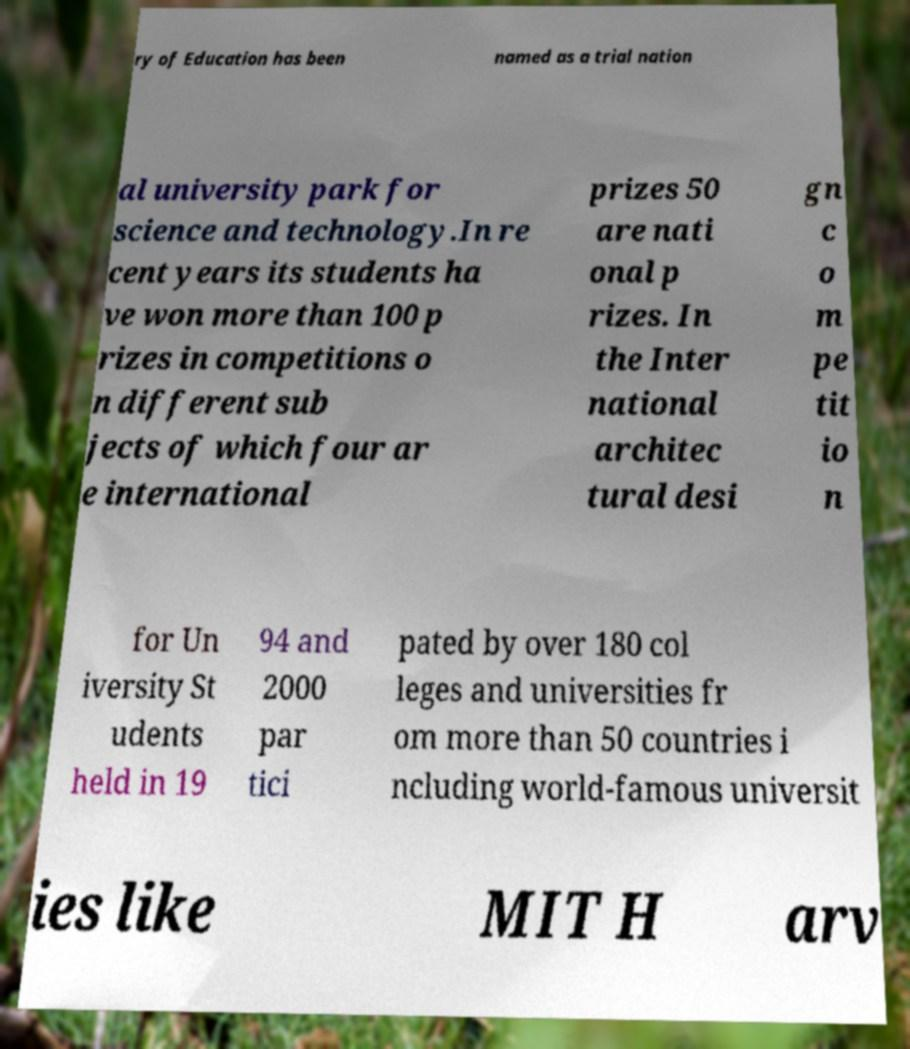Could you assist in decoding the text presented in this image and type it out clearly? ry of Education has been named as a trial nation al university park for science and technology.In re cent years its students ha ve won more than 100 p rizes in competitions o n different sub jects of which four ar e international prizes 50 are nati onal p rizes. In the Inter national architec tural desi gn c o m pe tit io n for Un iversity St udents held in 19 94 and 2000 par tici pated by over 180 col leges and universities fr om more than 50 countries i ncluding world-famous universit ies like MIT H arv 